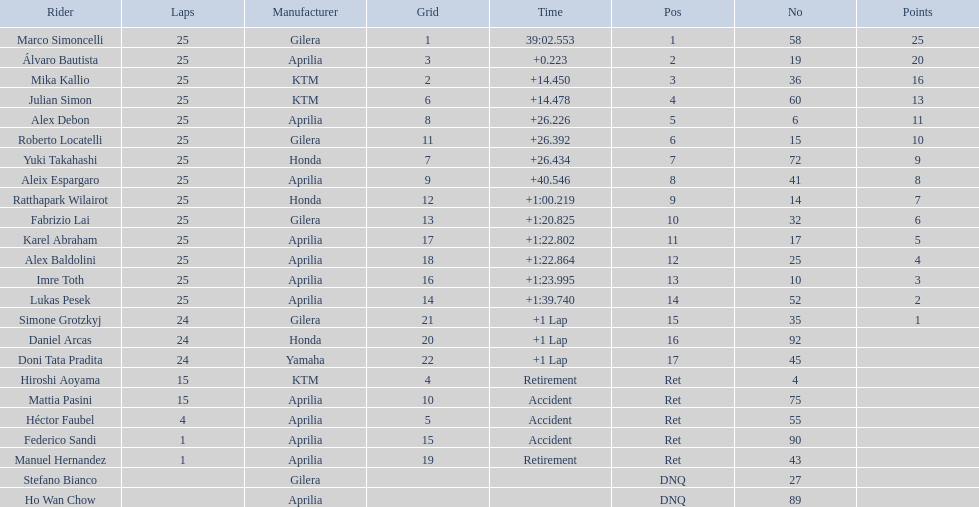The total amount of riders who did not qualify 2. 